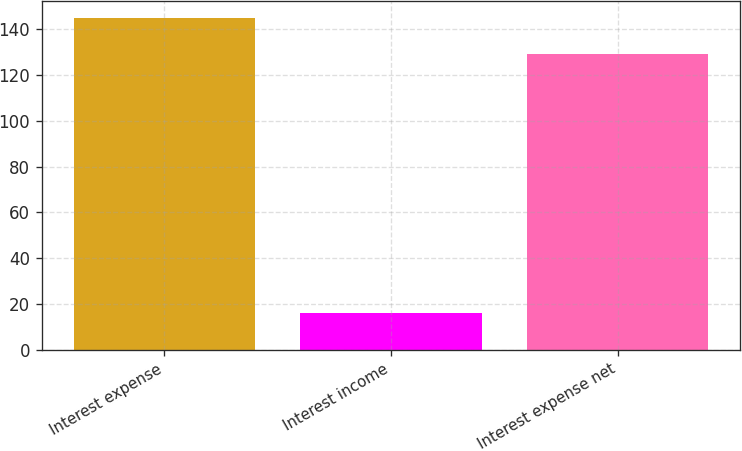Convert chart to OTSL. <chart><loc_0><loc_0><loc_500><loc_500><bar_chart><fcel>Interest expense<fcel>Interest income<fcel>Interest expense net<nl><fcel>145<fcel>16<fcel>129<nl></chart> 